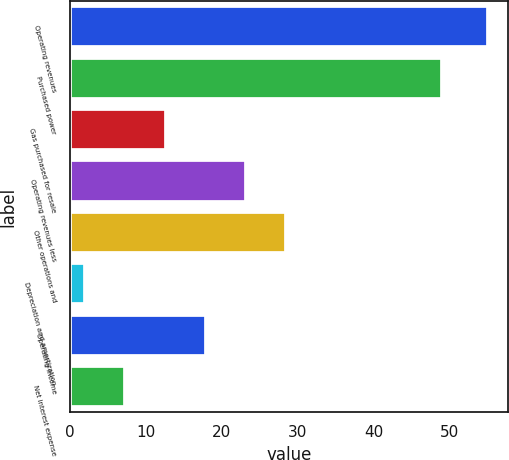<chart> <loc_0><loc_0><loc_500><loc_500><bar_chart><fcel>Operating revenues<fcel>Purchased power<fcel>Gas purchased for resale<fcel>Operating revenues less<fcel>Other operations and<fcel>Depreciation and amortization<fcel>Operating income<fcel>Net interest expense<nl><fcel>55<fcel>49<fcel>12.6<fcel>23.2<fcel>28.5<fcel>2<fcel>17.9<fcel>7.3<nl></chart> 